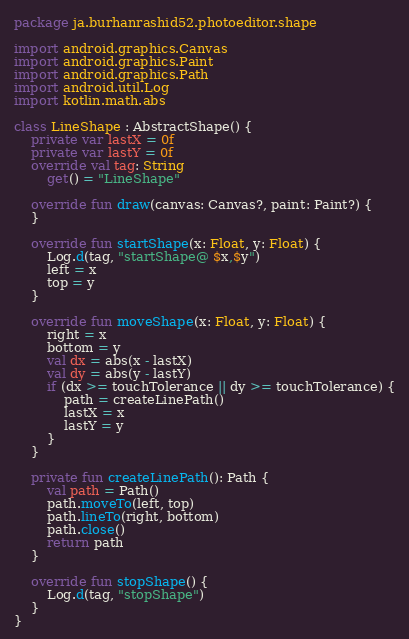<code> <loc_0><loc_0><loc_500><loc_500><_Kotlin_>package ja.burhanrashid52.photoeditor.shape

import android.graphics.Canvas
import android.graphics.Paint
import android.graphics.Path
import android.util.Log
import kotlin.math.abs

class LineShape : AbstractShape() {
    private var lastX = 0f
    private var lastY = 0f
    override val tag: String
        get() = "LineShape"

    override fun draw(canvas: Canvas?, paint: Paint?) {
    }

    override fun startShape(x: Float, y: Float) {
        Log.d(tag, "startShape@ $x,$y")
        left = x
        top = y
    }

    override fun moveShape(x: Float, y: Float) {
        right = x
        bottom = y
        val dx = abs(x - lastX)
        val dy = abs(y - lastY)
        if (dx >= touchTolerance || dy >= touchTolerance) {
            path = createLinePath()
            lastX = x
            lastY = y
        }
    }

    private fun createLinePath(): Path {
        val path = Path()
        path.moveTo(left, top)
        path.lineTo(right, bottom)
        path.close()
        return path
    }

    override fun stopShape() {
        Log.d(tag, "stopShape")
    }
}</code> 